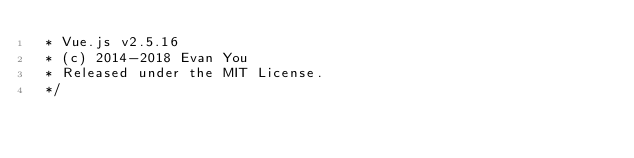<code> <loc_0><loc_0><loc_500><loc_500><_JavaScript_> * Vue.js v2.5.16
 * (c) 2014-2018 Evan You
 * Released under the MIT License.
 */</code> 